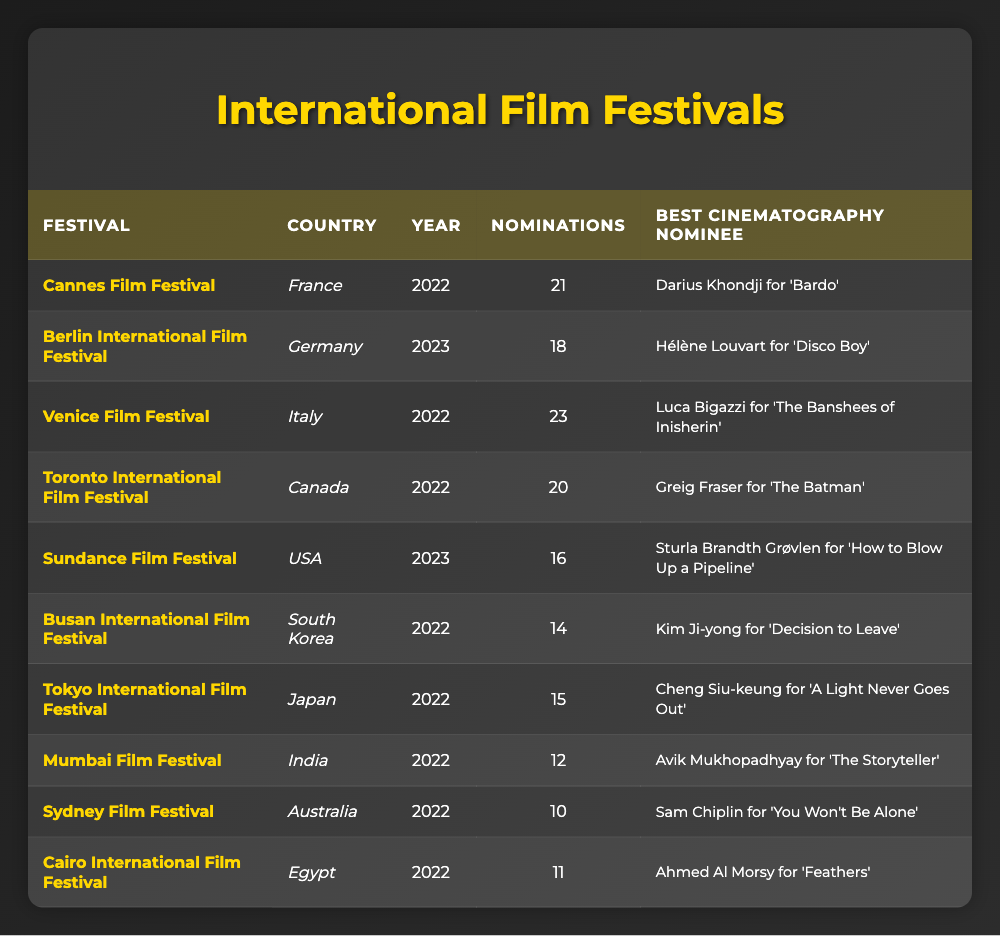What country hosted the Venice Film Festival in 2022? The table indicates that the Venice Film Festival took place in Italy in 2022.
Answer: Italy Who was nominated for Best Cinematography at the Berlin International Film Festival in 2023? According to the table, Hélène Louvart was nominated for Best Cinematography for the film 'Disco Boy' at the Berlin International Film Festival in 2023.
Answer: Hélène Louvart How many nominations did the Cairo International Film Festival receive in 2022? The table shows that the Cairo International Film Festival had 11 nominations in 2022.
Answer: 11 Which festival had the highest number of nominations in 2022? By reviewing the nominations in 2022 for each festival, the Venice Film Festival had the highest at 23 nominations.
Answer: Venice Film Festival What is the difference in nominations between the Cannes Film Festival and the Toronto International Film Festival in 2022? The Cannes Film Festival had 21 nominations while the Toronto International Film Festival had 20 nominations. The difference is 21 - 20 = 1.
Answer: 1 Which two festivals were held in 2022 and had the same number of nominations? The Busan International Film Festival and the Mumbai Film Festival both had 12 nominations in 2022 according to the data.
Answer: Busan and Mumbai Is there a Best Cinematography nominee for the Sydney Film Festival in 2022? Yes, the nominee for Best Cinematography at the Sydney Film Festival in 2022 was Sam Chiplin for 'You Won't Be Alone.'
Answer: Yes Which country had the least nominations in 2022? By comparing the nominations, the Sydney Film Festival in Australia had the least with 10 nominations in 2022.
Answer: Australia What was the average number of nominations for festivals in 2022? To find the average, sum all nominations from 2022: 21 + 23 + 20 + 14 + 15 + 12 + 10 + 11 =  126. There are 8 festivals, so the average is 126 / 8 = 15.75.
Answer: 15.75 Which film received the Best Cinematography nomination for the USA at the Sundance Film Festival in 2023? The table states that Sturla Brandth Grøvlen was the nominee for 'How to Blow Up a Pipeline' at the Sundance Film Festival in 2023.
Answer: 'How to Blow Up a Pipeline' 